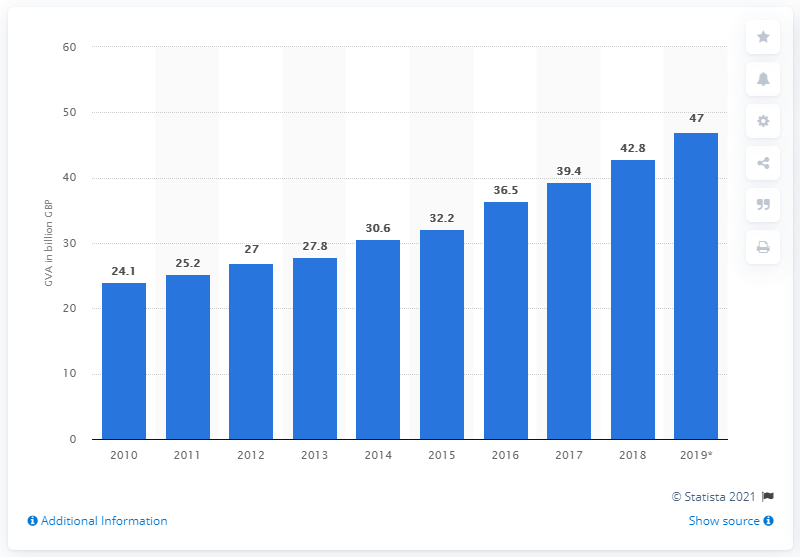Outline some significant characteristics in this image. In 2019, the gross value added of the IT, software and computer services industry in the UK was approximately £47 billion. 